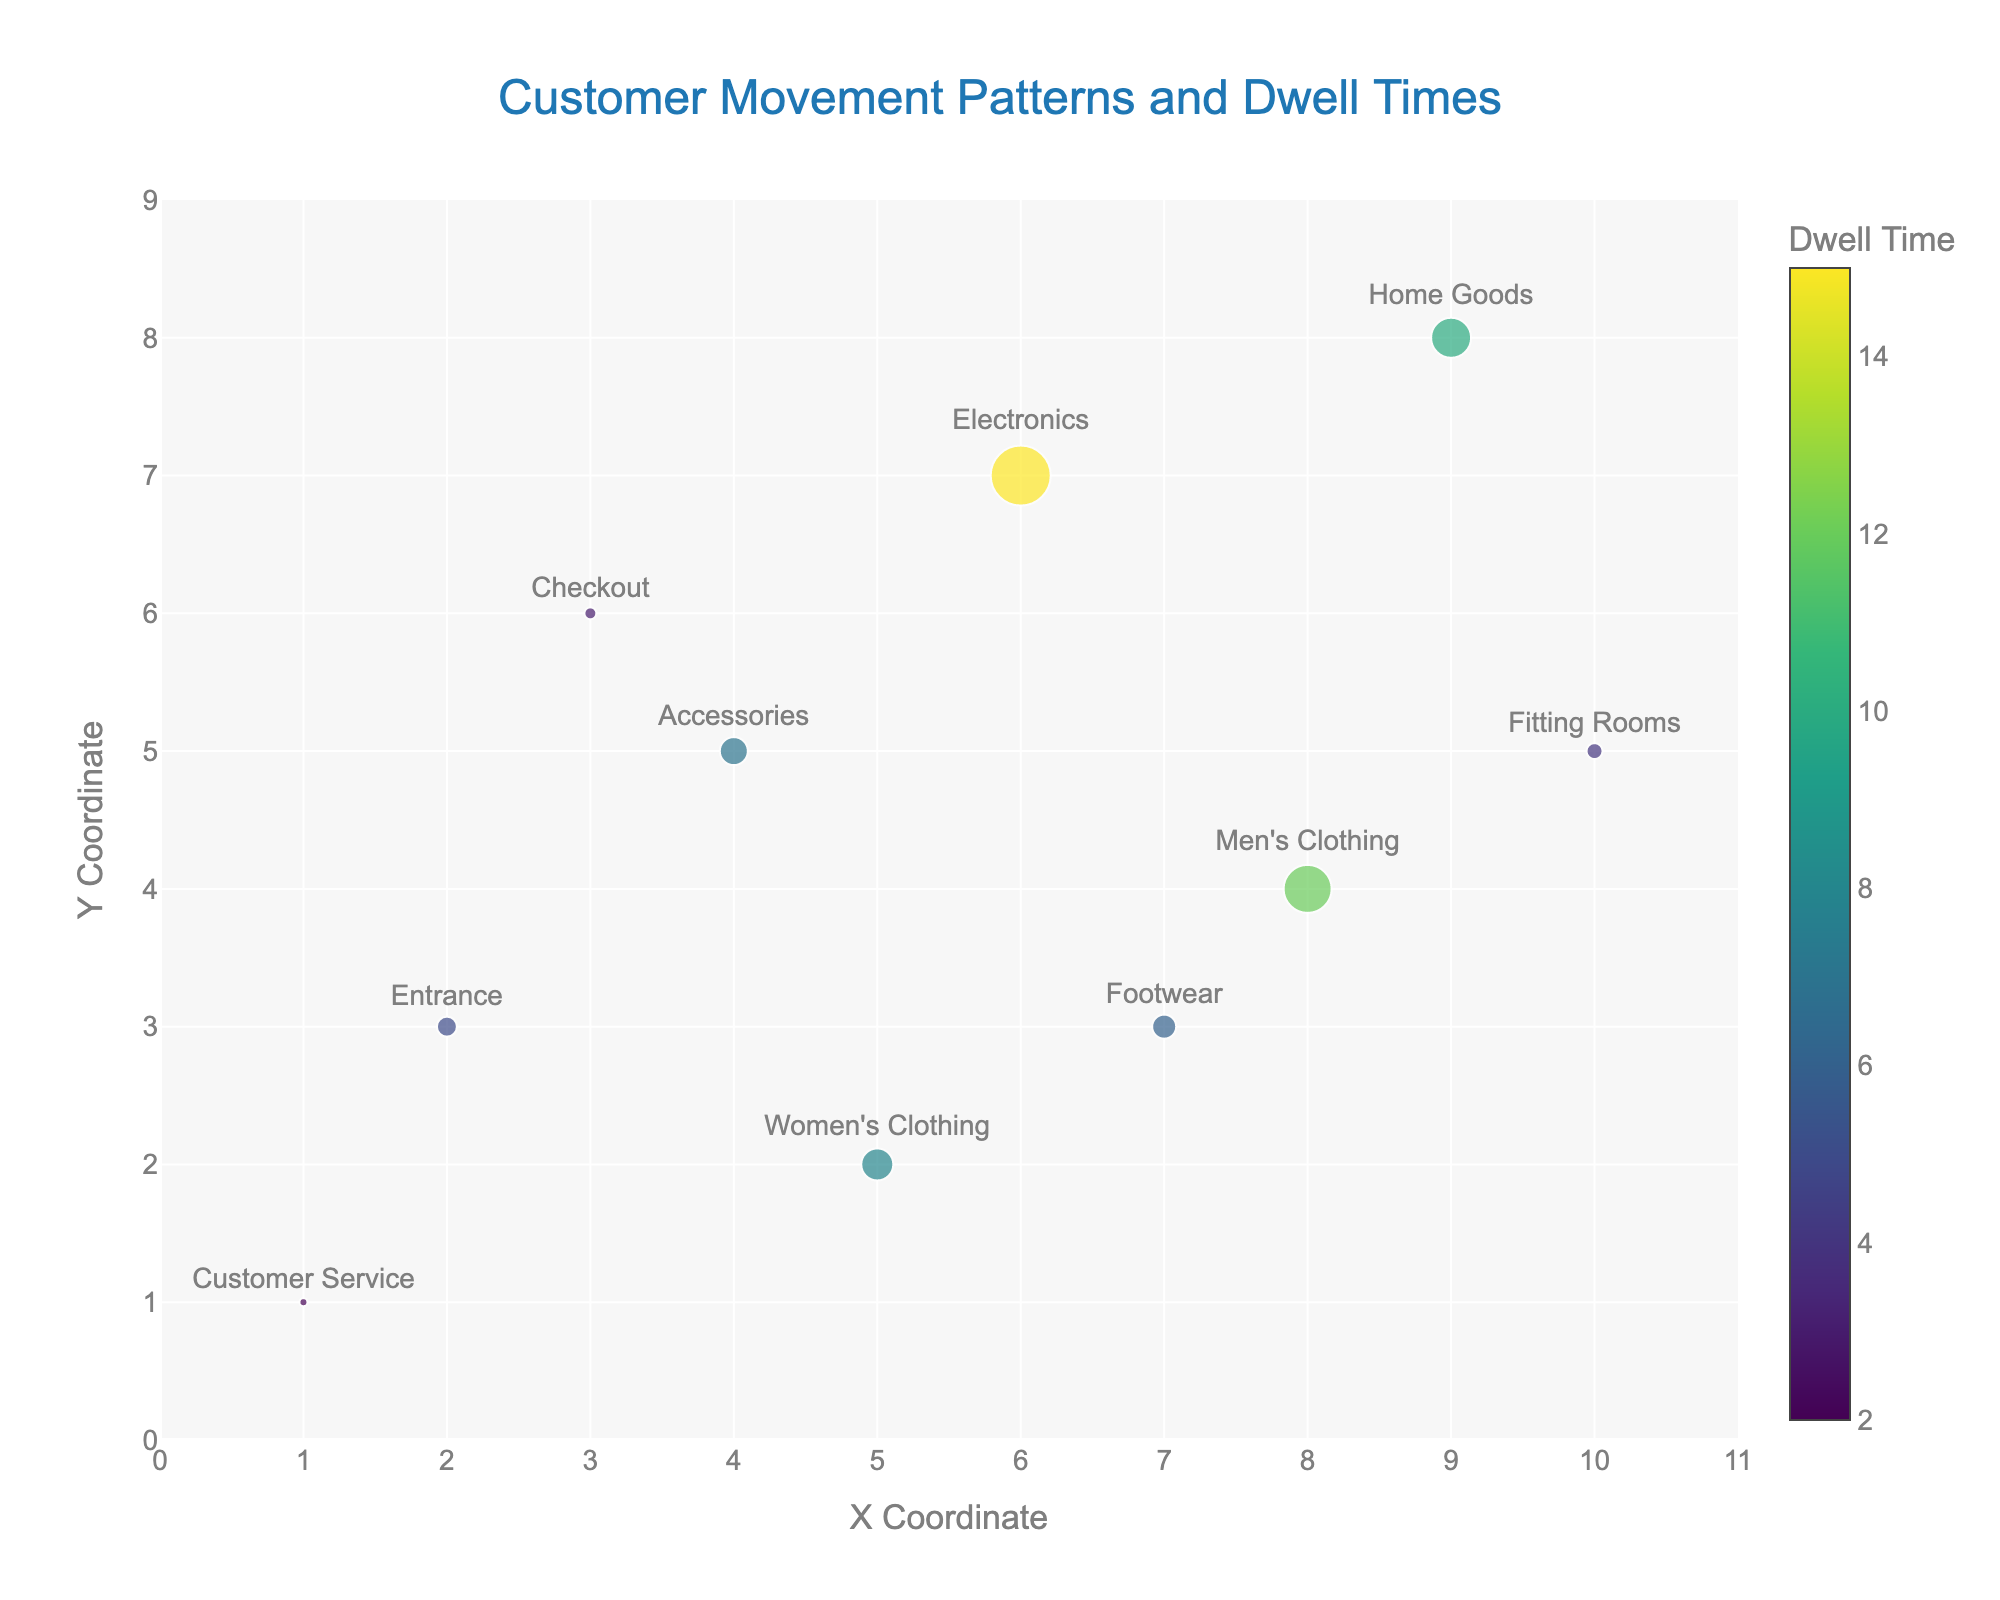What is the color scale used to represent dwell times in the plot? The dwell times are represented using a Viridis color scale. This scale is shown in the color bar, where different colors correspond to different dwell times.
Answer: Viridis How many areas have a dwell time greater than 10? To find the answer, look at the color scale and identify the areas with the corresponding colors indicating dwell times greater than 10. In this plot, Men's Clothing (12) and Electronics (15) have dwell times greater than 10.
Answer: Two In which area do customers have the longest dwell time? Examine the size and color of the markers, as larger and darker ones indicate longer dwell times. The largest and darkest marker is in Electronics, which has a dwell time of 15.
Answer: Electronics What is the direction of movement from the Entrance? For the Entrance, find the cone representing movement. The u value is 1 and v value is -0.5. This means the movement is to the right and slightly downward.
Answer: Right and slightly downward Which two areas have the same movement vector direction? Look for cones in the plot with identical orientations. Men's Clothing (u=-1, v=0.5) and Fitting Rooms (u=-1, v=-1) have different movement vectors. Only Footwear (u=0.5, v=-0.5) and Entrance (u=1, v=-0.5) have similar downward and right movement direction though not identical numerically.
Answer: Footwear and Entrance What is the total dwell time for the areas where u>0? Identify areas where u values are positive: Entrance, Women's Clothing, Electronics, Footwear, and Customer Service. Add their dwell times: (5 + 8 + 15 + 6 + 2) = 36.
Answer: 36 Which areas show movement directly upwards? Identify areas where the vector points straight up (u=0, v=1). Here, only Accessories have a vector pointing directly upwards.
Answer: Accessories How many areas have movement vectors with a horizontal component (u≠0)? Identify and count all areas where u is not equal to zero. These are Entrance (u=1), Women's Clothing (u=0.5), Men's Clothing (u=-1), Checkout (u=-0.5), Electronics (u=1), Home Goods (u=-0.5), Footwear (u=0.5), and Fitting Rooms (u=-1).
Answer: Eight Compare the dwell times between Men’s Clothing and Home Goods. Which has the higher dwell time? Look at the dwell times of Men’s Clothing (12) and Home Goods (10). 12 is greater than 10.
Answer: Men's Clothing 